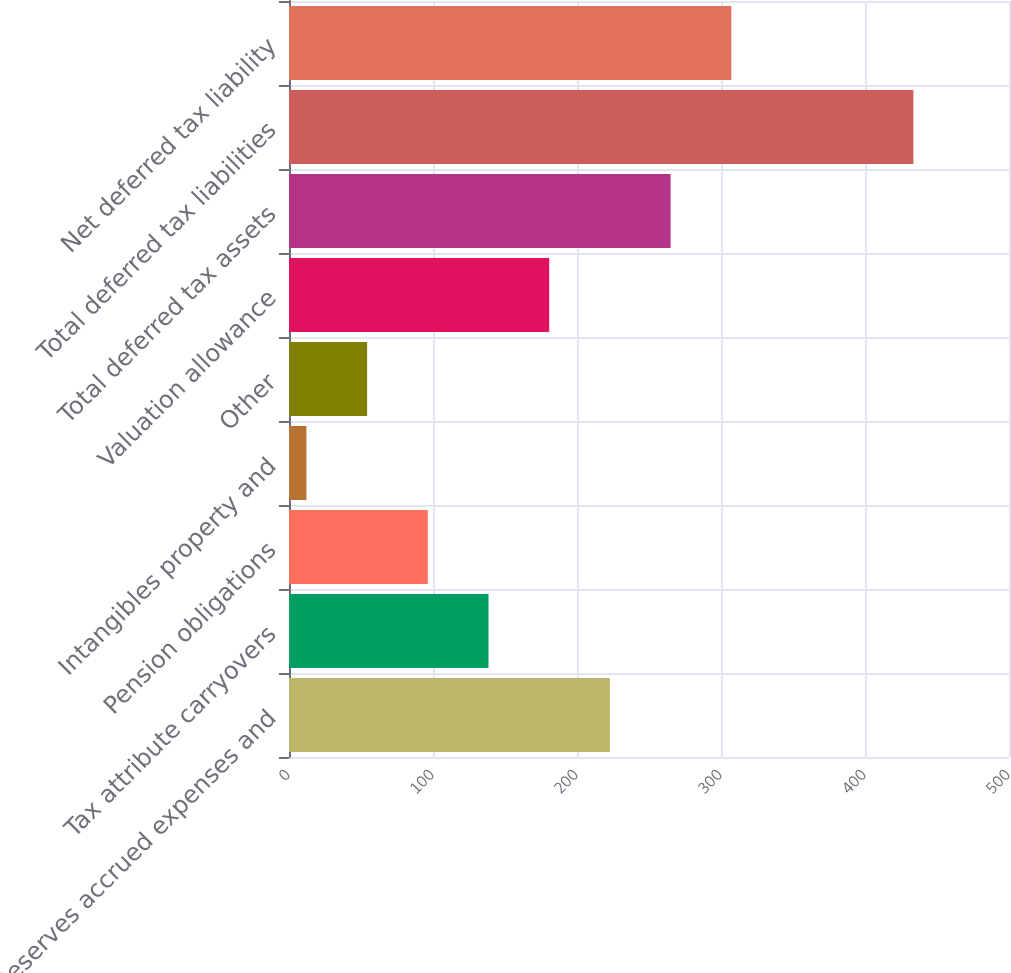Convert chart. <chart><loc_0><loc_0><loc_500><loc_500><bar_chart><fcel>Reserves accrued expenses and<fcel>Tax attribute carryovers<fcel>Pension obligations<fcel>Intangibles property and<fcel>Other<fcel>Valuation allowance<fcel>Total deferred tax assets<fcel>Total deferred tax liabilities<fcel>Net deferred tax liability<nl><fcel>222.85<fcel>138.55<fcel>96.4<fcel>12.1<fcel>54.25<fcel>180.7<fcel>265<fcel>433.6<fcel>307.15<nl></chart> 